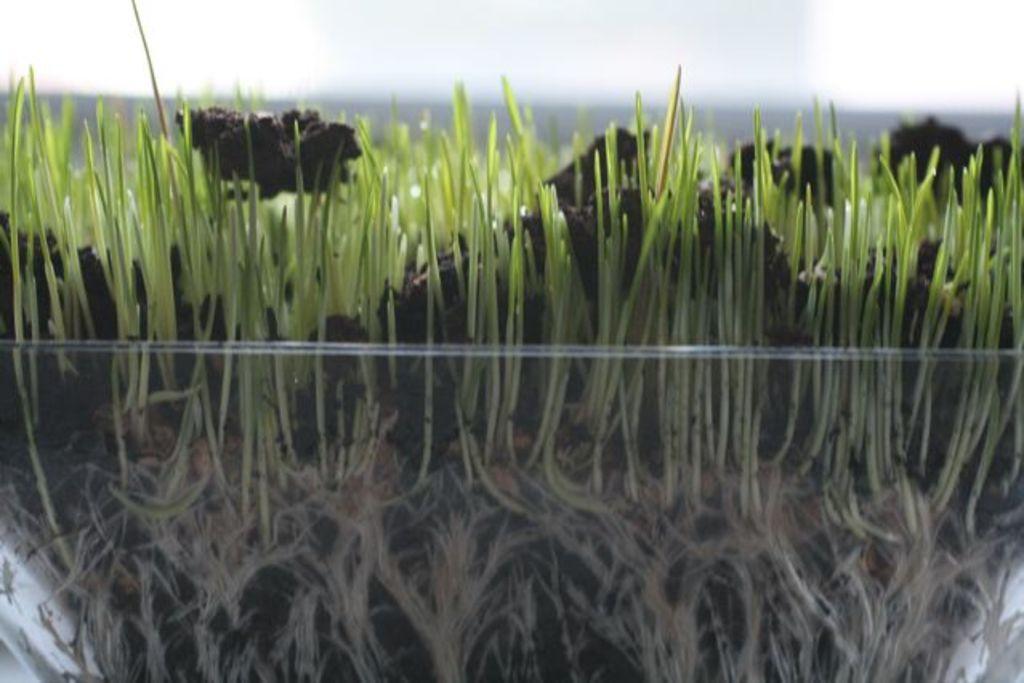In one or two sentences, can you explain what this image depicts? Here I can see a glass bowl in which I can see some plants and mud. On the top of the image I can see the sky. 